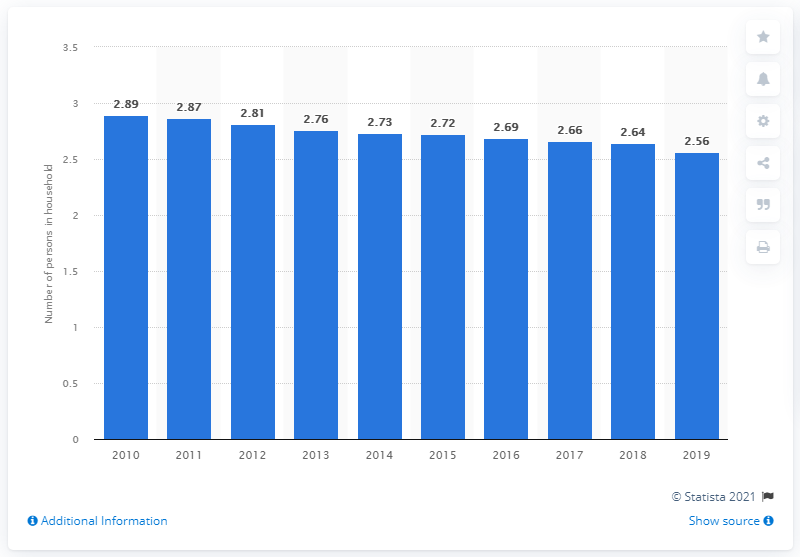Indicate a few pertinent items in this graphic. In 2019, the average number of people in a family in Poland was 2.56. 